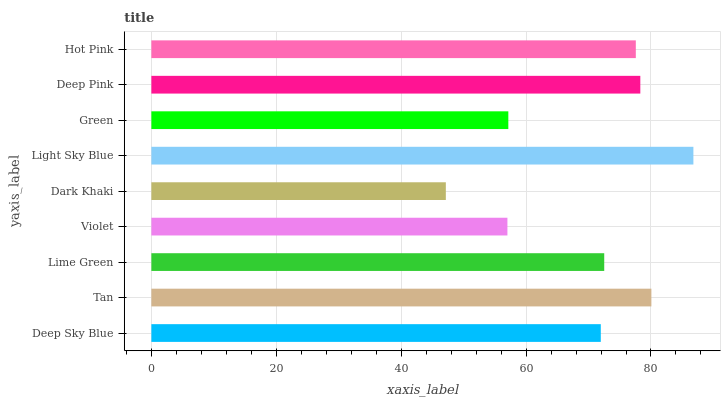Is Dark Khaki the minimum?
Answer yes or no. Yes. Is Light Sky Blue the maximum?
Answer yes or no. Yes. Is Tan the minimum?
Answer yes or no. No. Is Tan the maximum?
Answer yes or no. No. Is Tan greater than Deep Sky Blue?
Answer yes or no. Yes. Is Deep Sky Blue less than Tan?
Answer yes or no. Yes. Is Deep Sky Blue greater than Tan?
Answer yes or no. No. Is Tan less than Deep Sky Blue?
Answer yes or no. No. Is Lime Green the high median?
Answer yes or no. Yes. Is Lime Green the low median?
Answer yes or no. Yes. Is Deep Sky Blue the high median?
Answer yes or no. No. Is Light Sky Blue the low median?
Answer yes or no. No. 